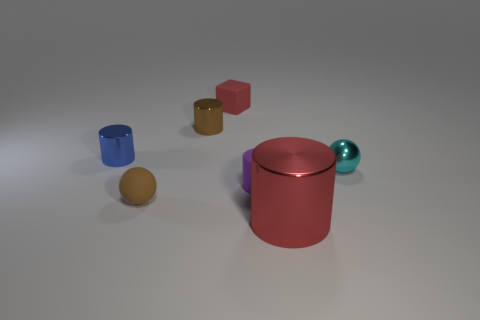There is another rubber thing that is the same shape as the small cyan thing; what is its size?
Provide a short and direct response. Small. There is a tiny thing that is on the left side of the small brown ball; what is its shape?
Provide a short and direct response. Cylinder. The small metallic object in front of the tiny blue cylinder that is behind the purple thing is what color?
Provide a succinct answer. Cyan. What number of things are either brown metal cylinders that are on the left side of the small rubber cylinder or tiny yellow rubber cylinders?
Offer a very short reply. 1. There is a blue metallic cylinder; is it the same size as the thing that is right of the red metal cylinder?
Give a very brief answer. Yes. How many small objects are either cyan shiny things or purple matte cylinders?
Keep it short and to the point. 2. What shape is the red matte object?
Your response must be concise. Cube. What is the size of the metal cylinder that is the same color as the tiny rubber sphere?
Provide a short and direct response. Small. Is there a small brown cylinder made of the same material as the red cube?
Provide a short and direct response. No. Is the number of cyan things greater than the number of blue blocks?
Provide a short and direct response. Yes. 